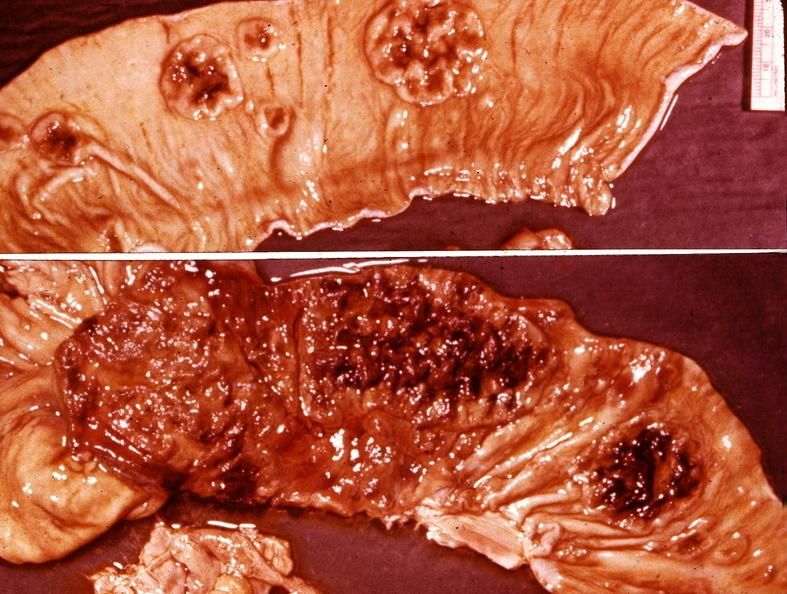where does this belong to?
Answer the question using a single word or phrase. Gastrointestinal system 